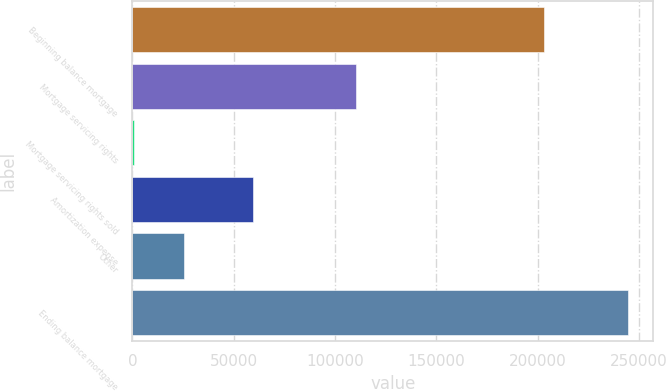Convert chart to OTSL. <chart><loc_0><loc_0><loc_500><loc_500><bar_chart><fcel>Beginning balance mortgage<fcel>Mortgage servicing rights<fcel>Mortgage servicing rights sold<fcel>Amortization expense<fcel>Other<fcel>Ending balance mortgage<nl><fcel>202982<fcel>110428<fcel>783<fcel>59608<fcel>25177<fcel>244723<nl></chart> 